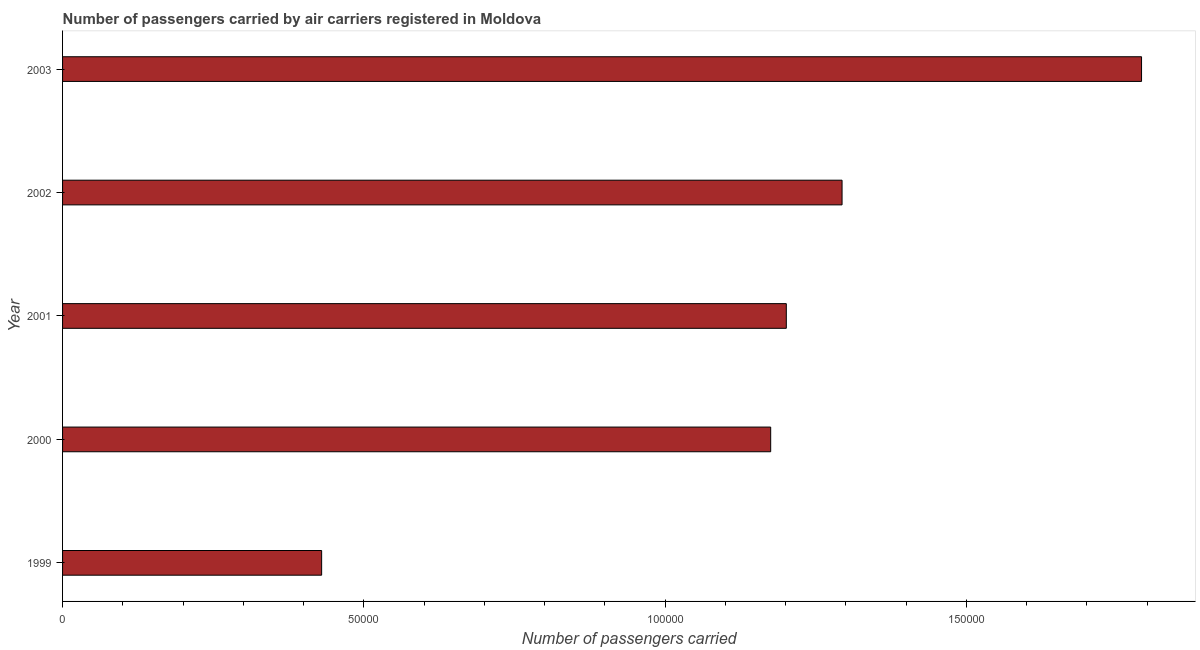Does the graph contain grids?
Offer a very short reply. No. What is the title of the graph?
Keep it short and to the point. Number of passengers carried by air carriers registered in Moldova. What is the label or title of the X-axis?
Offer a terse response. Number of passengers carried. What is the label or title of the Y-axis?
Offer a terse response. Year. What is the number of passengers carried in 2001?
Provide a succinct answer. 1.20e+05. Across all years, what is the maximum number of passengers carried?
Provide a succinct answer. 1.79e+05. Across all years, what is the minimum number of passengers carried?
Ensure brevity in your answer.  4.30e+04. What is the sum of the number of passengers carried?
Your answer should be very brief. 5.89e+05. What is the difference between the number of passengers carried in 1999 and 2000?
Give a very brief answer. -7.45e+04. What is the average number of passengers carried per year?
Offer a terse response. 1.18e+05. What is the median number of passengers carried?
Ensure brevity in your answer.  1.20e+05. In how many years, is the number of passengers carried greater than 90000 ?
Give a very brief answer. 4. Do a majority of the years between 2003 and 2000 (inclusive) have number of passengers carried greater than 120000 ?
Ensure brevity in your answer.  Yes. What is the ratio of the number of passengers carried in 1999 to that in 2001?
Provide a succinct answer. 0.36. Is the number of passengers carried in 2001 less than that in 2002?
Provide a succinct answer. Yes. Is the difference between the number of passengers carried in 2000 and 2003 greater than the difference between any two years?
Offer a terse response. No. What is the difference between the highest and the second highest number of passengers carried?
Your response must be concise. 4.97e+04. Is the sum of the number of passengers carried in 2000 and 2001 greater than the maximum number of passengers carried across all years?
Your answer should be very brief. Yes. What is the difference between the highest and the lowest number of passengers carried?
Offer a very short reply. 1.36e+05. Are all the bars in the graph horizontal?
Offer a very short reply. Yes. How many years are there in the graph?
Your response must be concise. 5. What is the difference between two consecutive major ticks on the X-axis?
Provide a succinct answer. 5.00e+04. What is the Number of passengers carried in 1999?
Offer a very short reply. 4.30e+04. What is the Number of passengers carried of 2000?
Offer a terse response. 1.18e+05. What is the Number of passengers carried of 2001?
Your response must be concise. 1.20e+05. What is the Number of passengers carried in 2002?
Provide a succinct answer. 1.29e+05. What is the Number of passengers carried in 2003?
Your answer should be very brief. 1.79e+05. What is the difference between the Number of passengers carried in 1999 and 2000?
Ensure brevity in your answer.  -7.45e+04. What is the difference between the Number of passengers carried in 1999 and 2001?
Your answer should be compact. -7.71e+04. What is the difference between the Number of passengers carried in 1999 and 2002?
Your answer should be very brief. -8.64e+04. What is the difference between the Number of passengers carried in 1999 and 2003?
Make the answer very short. -1.36e+05. What is the difference between the Number of passengers carried in 2000 and 2001?
Give a very brief answer. -2593. What is the difference between the Number of passengers carried in 2000 and 2002?
Your answer should be compact. -1.18e+04. What is the difference between the Number of passengers carried in 2000 and 2003?
Your answer should be very brief. -6.16e+04. What is the difference between the Number of passengers carried in 2001 and 2002?
Offer a terse response. -9252. What is the difference between the Number of passengers carried in 2001 and 2003?
Your answer should be very brief. -5.90e+04. What is the difference between the Number of passengers carried in 2002 and 2003?
Make the answer very short. -4.97e+04. What is the ratio of the Number of passengers carried in 1999 to that in 2000?
Ensure brevity in your answer.  0.37. What is the ratio of the Number of passengers carried in 1999 to that in 2001?
Offer a very short reply. 0.36. What is the ratio of the Number of passengers carried in 1999 to that in 2002?
Keep it short and to the point. 0.33. What is the ratio of the Number of passengers carried in 1999 to that in 2003?
Offer a very short reply. 0.24. What is the ratio of the Number of passengers carried in 2000 to that in 2001?
Provide a succinct answer. 0.98. What is the ratio of the Number of passengers carried in 2000 to that in 2002?
Provide a succinct answer. 0.91. What is the ratio of the Number of passengers carried in 2000 to that in 2003?
Offer a terse response. 0.66. What is the ratio of the Number of passengers carried in 2001 to that in 2002?
Your answer should be very brief. 0.93. What is the ratio of the Number of passengers carried in 2001 to that in 2003?
Your response must be concise. 0.67. What is the ratio of the Number of passengers carried in 2002 to that in 2003?
Offer a terse response. 0.72. 